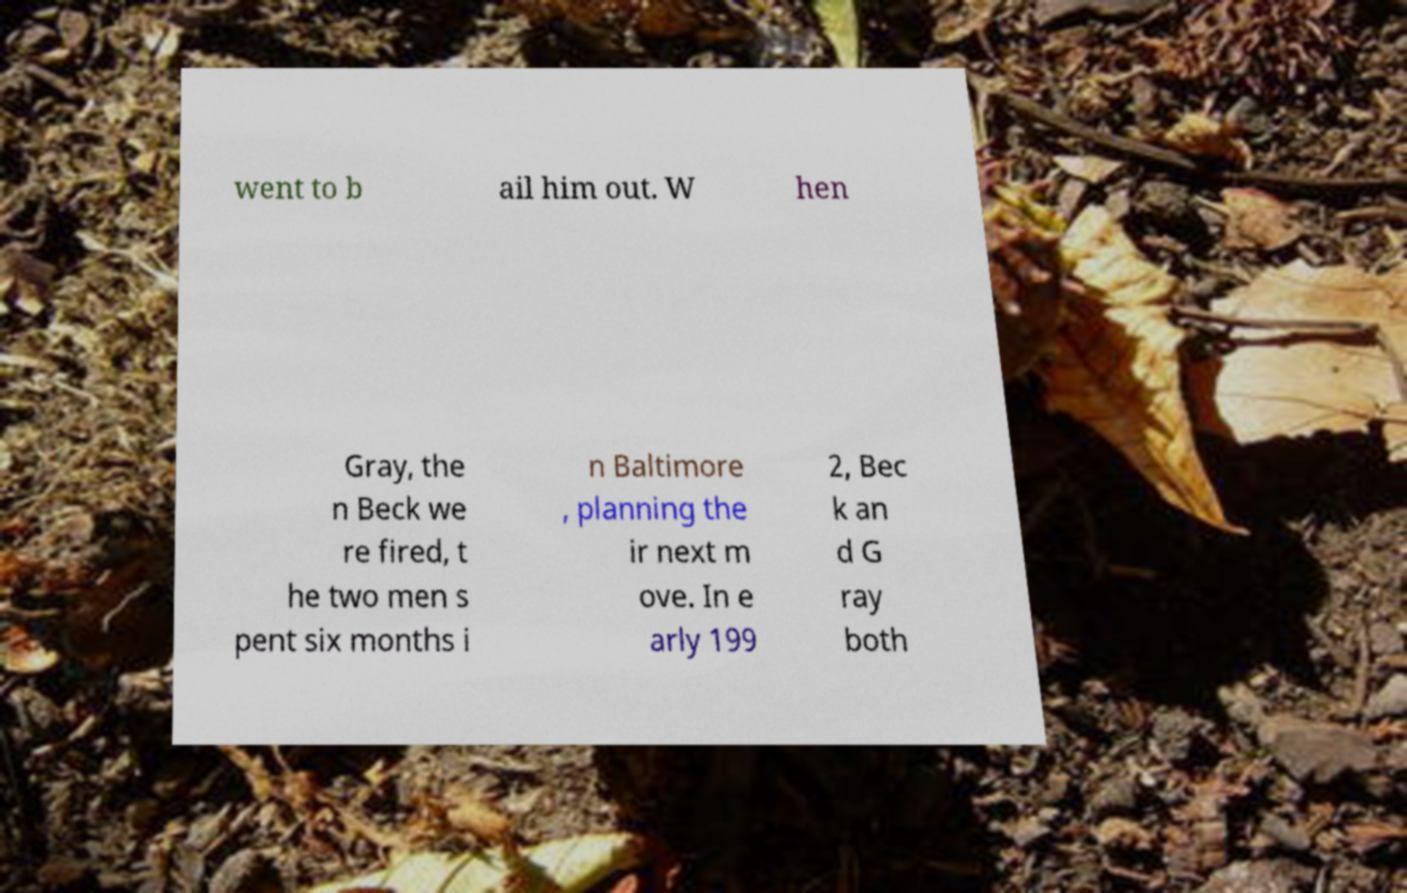Can you read and provide the text displayed in the image?This photo seems to have some interesting text. Can you extract and type it out for me? went to b ail him out. W hen Gray, the n Beck we re fired, t he two men s pent six months i n Baltimore , planning the ir next m ove. In e arly 199 2, Bec k an d G ray both 